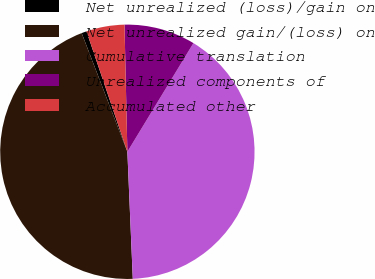Convert chart to OTSL. <chart><loc_0><loc_0><loc_500><loc_500><pie_chart><fcel>Net unrealized (loss)/gain on<fcel>Net unrealized gain/(loss) on<fcel>Cumulative translation<fcel>Unrealized components of<fcel>Accumulated other<nl><fcel>0.64%<fcel>44.83%<fcel>40.63%<fcel>9.05%<fcel>4.85%<nl></chart> 